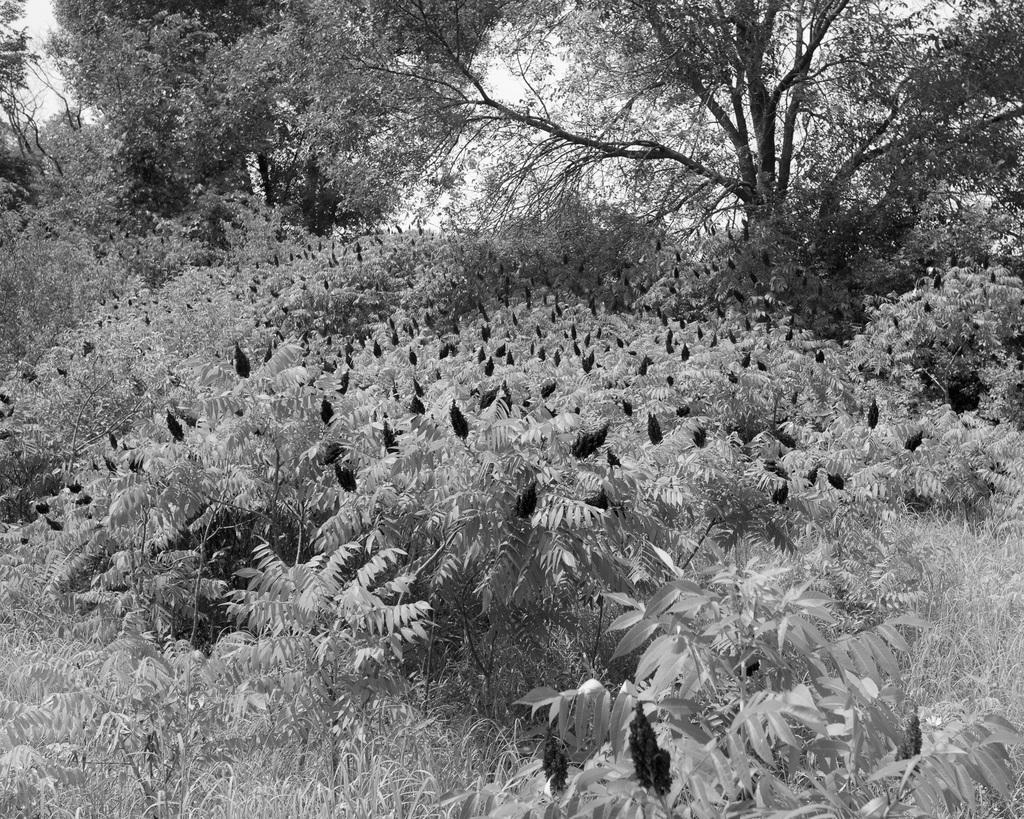Please provide a concise description of this image. In this picture I can see few bushes in the middle. In the background there are trees, this image is in black and white color. 